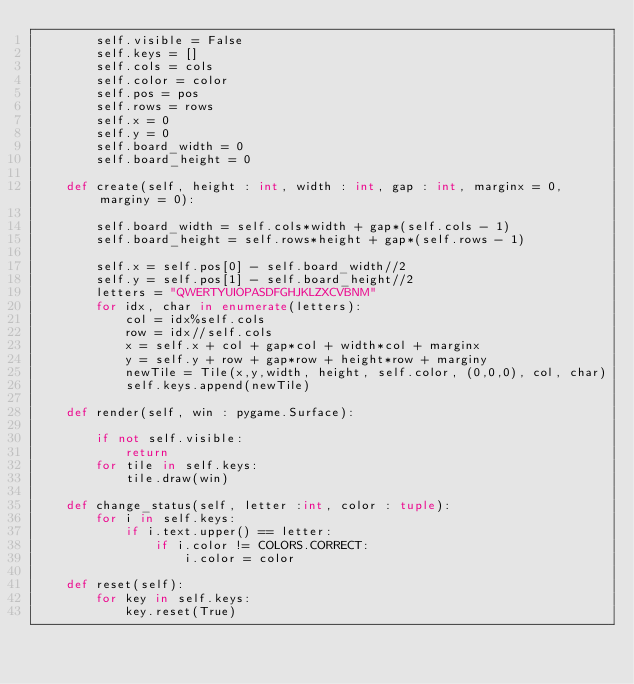<code> <loc_0><loc_0><loc_500><loc_500><_Python_>        self.visible = False
        self.keys = []
        self.cols = cols
        self.color = color
        self.pos = pos
        self.rows = rows
        self.x = 0
        self.y = 0
        self.board_width = 0
        self.board_height = 0

    def create(self, height : int, width : int, gap : int, marginx = 0, marginy = 0):

        self.board_width = self.cols*width + gap*(self.cols - 1)
        self.board_height = self.rows*height + gap*(self.rows - 1)

        self.x = self.pos[0] - self.board_width//2
        self.y = self.pos[1] - self.board_height//2
        letters = "QWERTYUIOPASDFGHJKLZXCVBNM"
        for idx, char in enumerate(letters):
            col = idx%self.cols
            row = idx//self.cols
            x = self.x + col + gap*col + width*col + marginx
            y = self.y + row + gap*row + height*row + marginy
            newTile = Tile(x,y,width, height, self.color, (0,0,0), col, char)
            self.keys.append(newTile)

    def render(self, win : pygame.Surface):

        if not self.visible:
            return
        for tile in self.keys:
            tile.draw(win)

    def change_status(self, letter :int, color : tuple):
        for i in self.keys:
            if i.text.upper() == letter:
                if i.color != COLORS.CORRECT:
                    i.color = color

    def reset(self):
        for key in self.keys:
            key.reset(True)
        </code> 